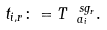Convert formula to latex. <formula><loc_0><loc_0><loc_500><loc_500>t _ { i , r } \colon = T _ { \ a _ { i } } ^ { \ s g _ { r } } .</formula> 